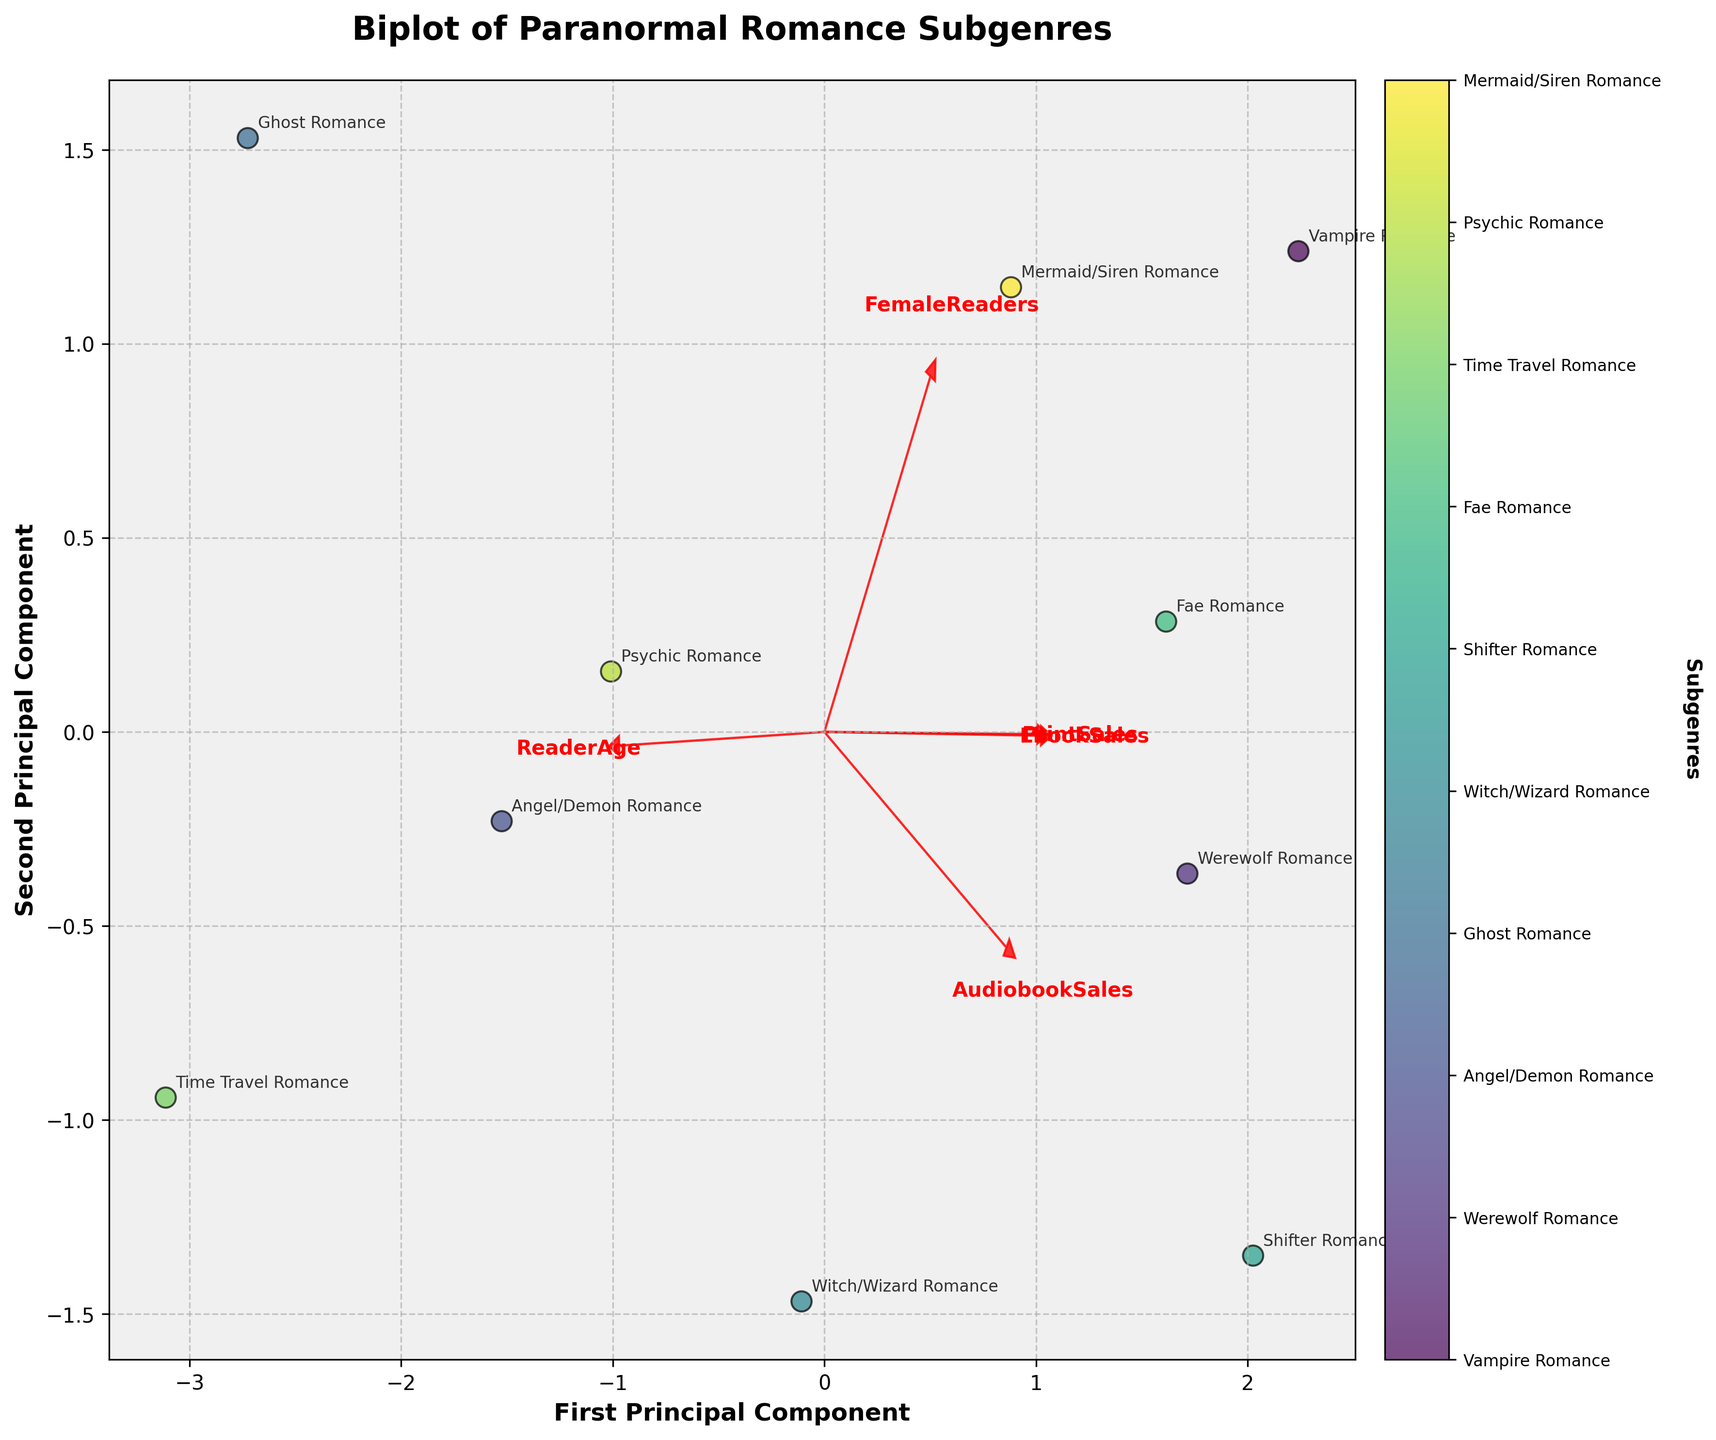What's the title of the plot? The title is prominently located at the top center of the plot. It should be clear and easy to read.
Answer: Biplot of Paranormal Romance Subgenres How many subgenres are represented in the plot? Count the number of unique annotations around the data points. Each annotation corresponds to a subgenre.
Answer: 10 What do the arrows represent in the biplot? The arrows represent the loading vectors for each feature. They show the direction and magnitude of each feature's contribution to the principal components.
Answer: Loading vectors for features Which subgenre has the highest association with print sales? Identify the direction of the 'PrintSales' arrow and observe which subgenre's data points are closest to this direction.
Answer: Vampire Romance How are 'FemaleReaders' and 'ReaderAge' related in this biplot? Look at the directions of the loading vectors for 'FemaleReaders' and 'ReaderAge'. If they point in similar directions, they are positively correlated; opposite directions indicate negative correlation. In this biplot, if the vectors for 'FemaleReaders' and 'ReaderAge' are pointing in different directions, they are negatively correlated.
Answer: Negatively correlated How does 'Witch/Wizard Romance' compare to 'Vampire Romance' in terms of EbookSales? Examine the position of the 'Witch/Wizard Romance' and 'Vampire Romance' data points relative to the direction of the 'EbookSales' arrow. 'Vampire Romance' is closer to the direction of 'EbookSales', indicating higher E-book sales compared to 'Witch/Wizard Romance'.
Answer: Vampire Romance has higher EbookSales Which feature has the least variance explained by the principal components? The length of the arrows represents the variance explained by the corresponding feature. The shortest arrow indicates the feature with the least variance explained.
Answer: FemaleReaders What can you infer about 'Ghost Romance' considering the first and second principal components? Identify the position of the 'Ghost Romance' data point along the first and second principal components. It is far from the origin and toward the bottom-left quadrant, indicating distinct characteristics compared to other subgenres.
Answer: Distinct characteristics in ReaderAge and PrintSales Which subgenre has an average reader age closer to the EbookSales direction? Compare the position of each subgenre along the 'EbookSales' arrow to their ReaderAge direction. 'Vampire Romance' appears to be slightly closer to the direction of EbookSales among those with an average reader age.
Answer: Vampire Romance 